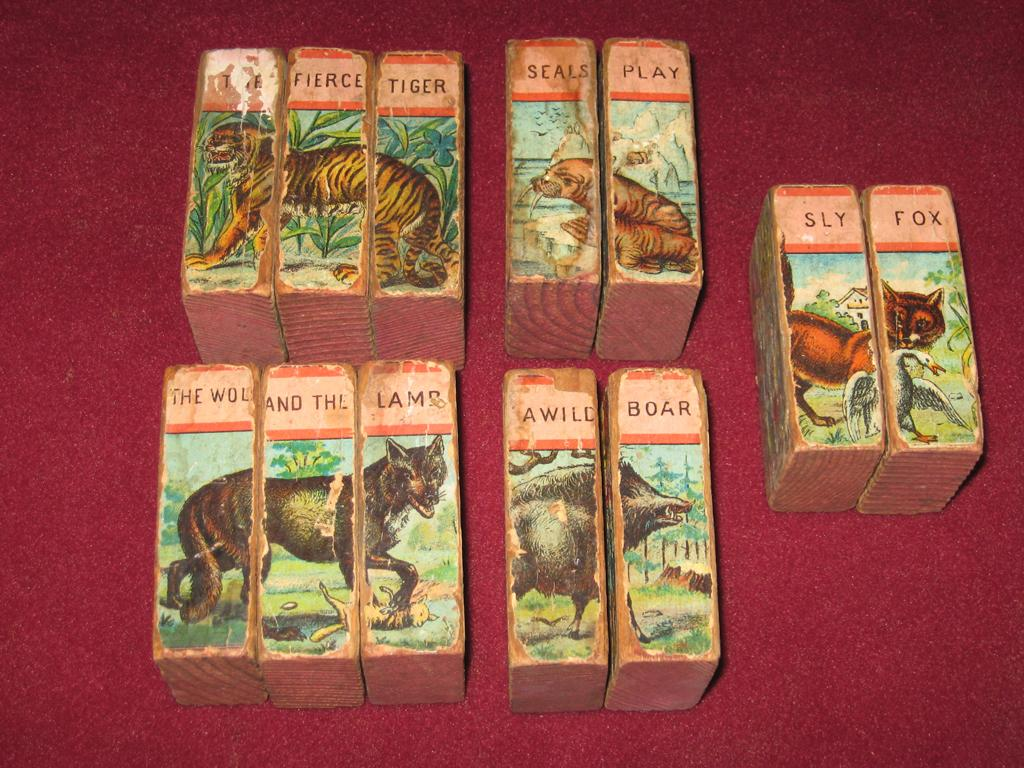What type of activity is depicted in the image? The image features puzzles. What material are the puzzles made of? The puzzles are made up of wooden blocks. What is shown on the wooden blocks? The wooden blocks have stickers of animals on them. What type of trains can be seen in the image? There are no trains present in the image; it features puzzles made of wooden blocks with animal stickers. How many deer are visible in the image? There are no deer present in the image; it features puzzles made of wooden blocks with animal stickers, but no deer are depicted. 